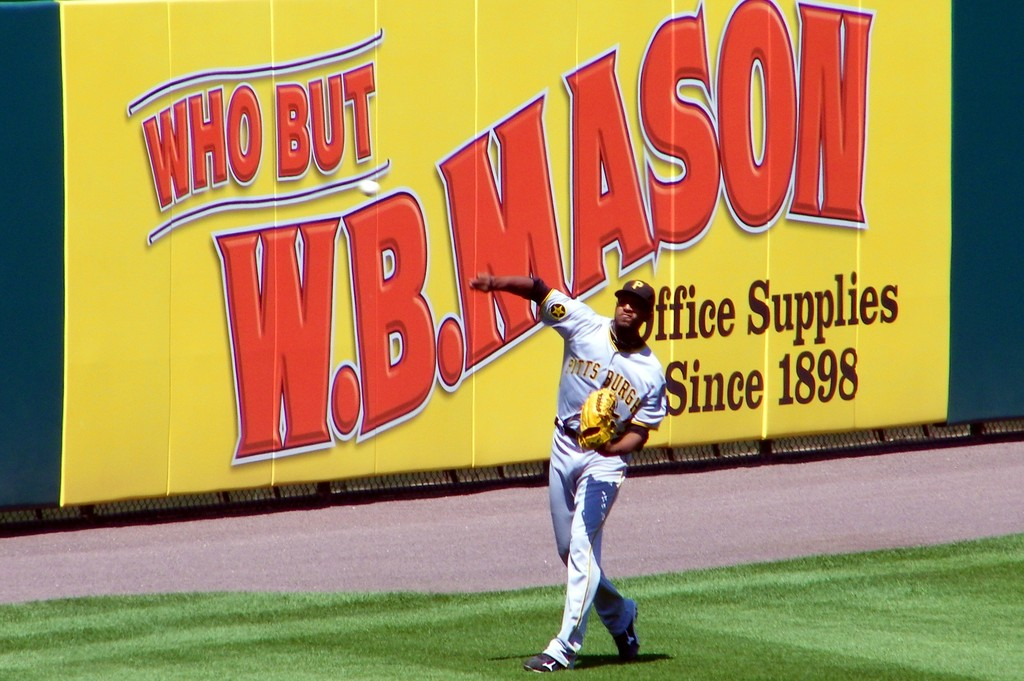Can you speculate on the type of event occurring in this scene? This appears to be a professional baseball game, possibly during a regular season match or practice, given the structured setting in a stadium with sponsorship banners like that of W.B. Mason. 